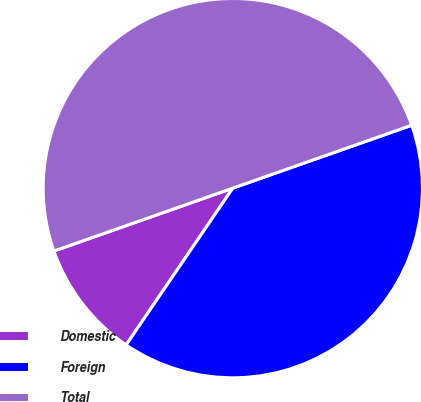Convert chart. <chart><loc_0><loc_0><loc_500><loc_500><pie_chart><fcel>Domestic<fcel>Foreign<fcel>Total<nl><fcel>10.11%<fcel>39.89%<fcel>50.0%<nl></chart> 